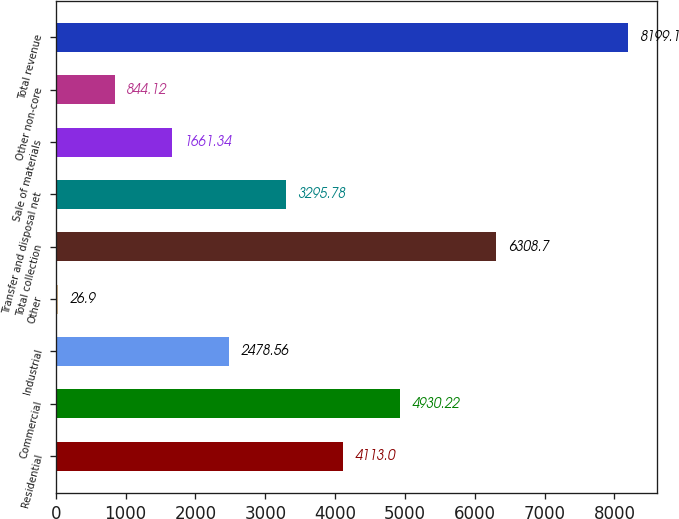Convert chart. <chart><loc_0><loc_0><loc_500><loc_500><bar_chart><fcel>Residential<fcel>Commercial<fcel>Industrial<fcel>Other<fcel>Total collection<fcel>Transfer and disposal net<fcel>Sale of materials<fcel>Other non-core<fcel>Total revenue<nl><fcel>4113<fcel>4930.22<fcel>2478.56<fcel>26.9<fcel>6308.7<fcel>3295.78<fcel>1661.34<fcel>844.12<fcel>8199.1<nl></chart> 